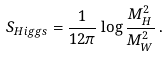Convert formula to latex. <formula><loc_0><loc_0><loc_500><loc_500>S _ { H i g g s } = \frac { 1 } { 1 2 \pi } \log \frac { M _ { H } ^ { 2 } } { M _ { W } ^ { 2 } } \, .</formula> 